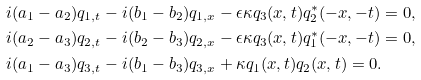<formula> <loc_0><loc_0><loc_500><loc_500>& i ( a _ { 1 } - a _ { 2 } ) q _ { 1 , t } - i ( b _ { 1 } - b _ { 2 } ) q _ { 1 , x } - \epsilon \kappa q _ { 3 } ( x , t ) q _ { 2 } ^ { * } ( - x , - t ) = 0 , \\ & i ( a _ { 2 } - a _ { 3 } ) q _ { 2 , t } - i ( b _ { 2 } - b _ { 3 } ) q _ { 2 , x } - \epsilon \kappa q _ { 3 } ( x , t ) q _ { 1 } ^ { * } ( - x , - t ) = 0 , \\ & i ( a _ { 1 } - a _ { 3 } ) q _ { 3 , t } - i ( b _ { 1 } - b _ { 3 } ) q _ { 3 , x } + \kappa q _ { 1 } ( x , t ) q _ { 2 } ( x , t ) = 0 .</formula> 